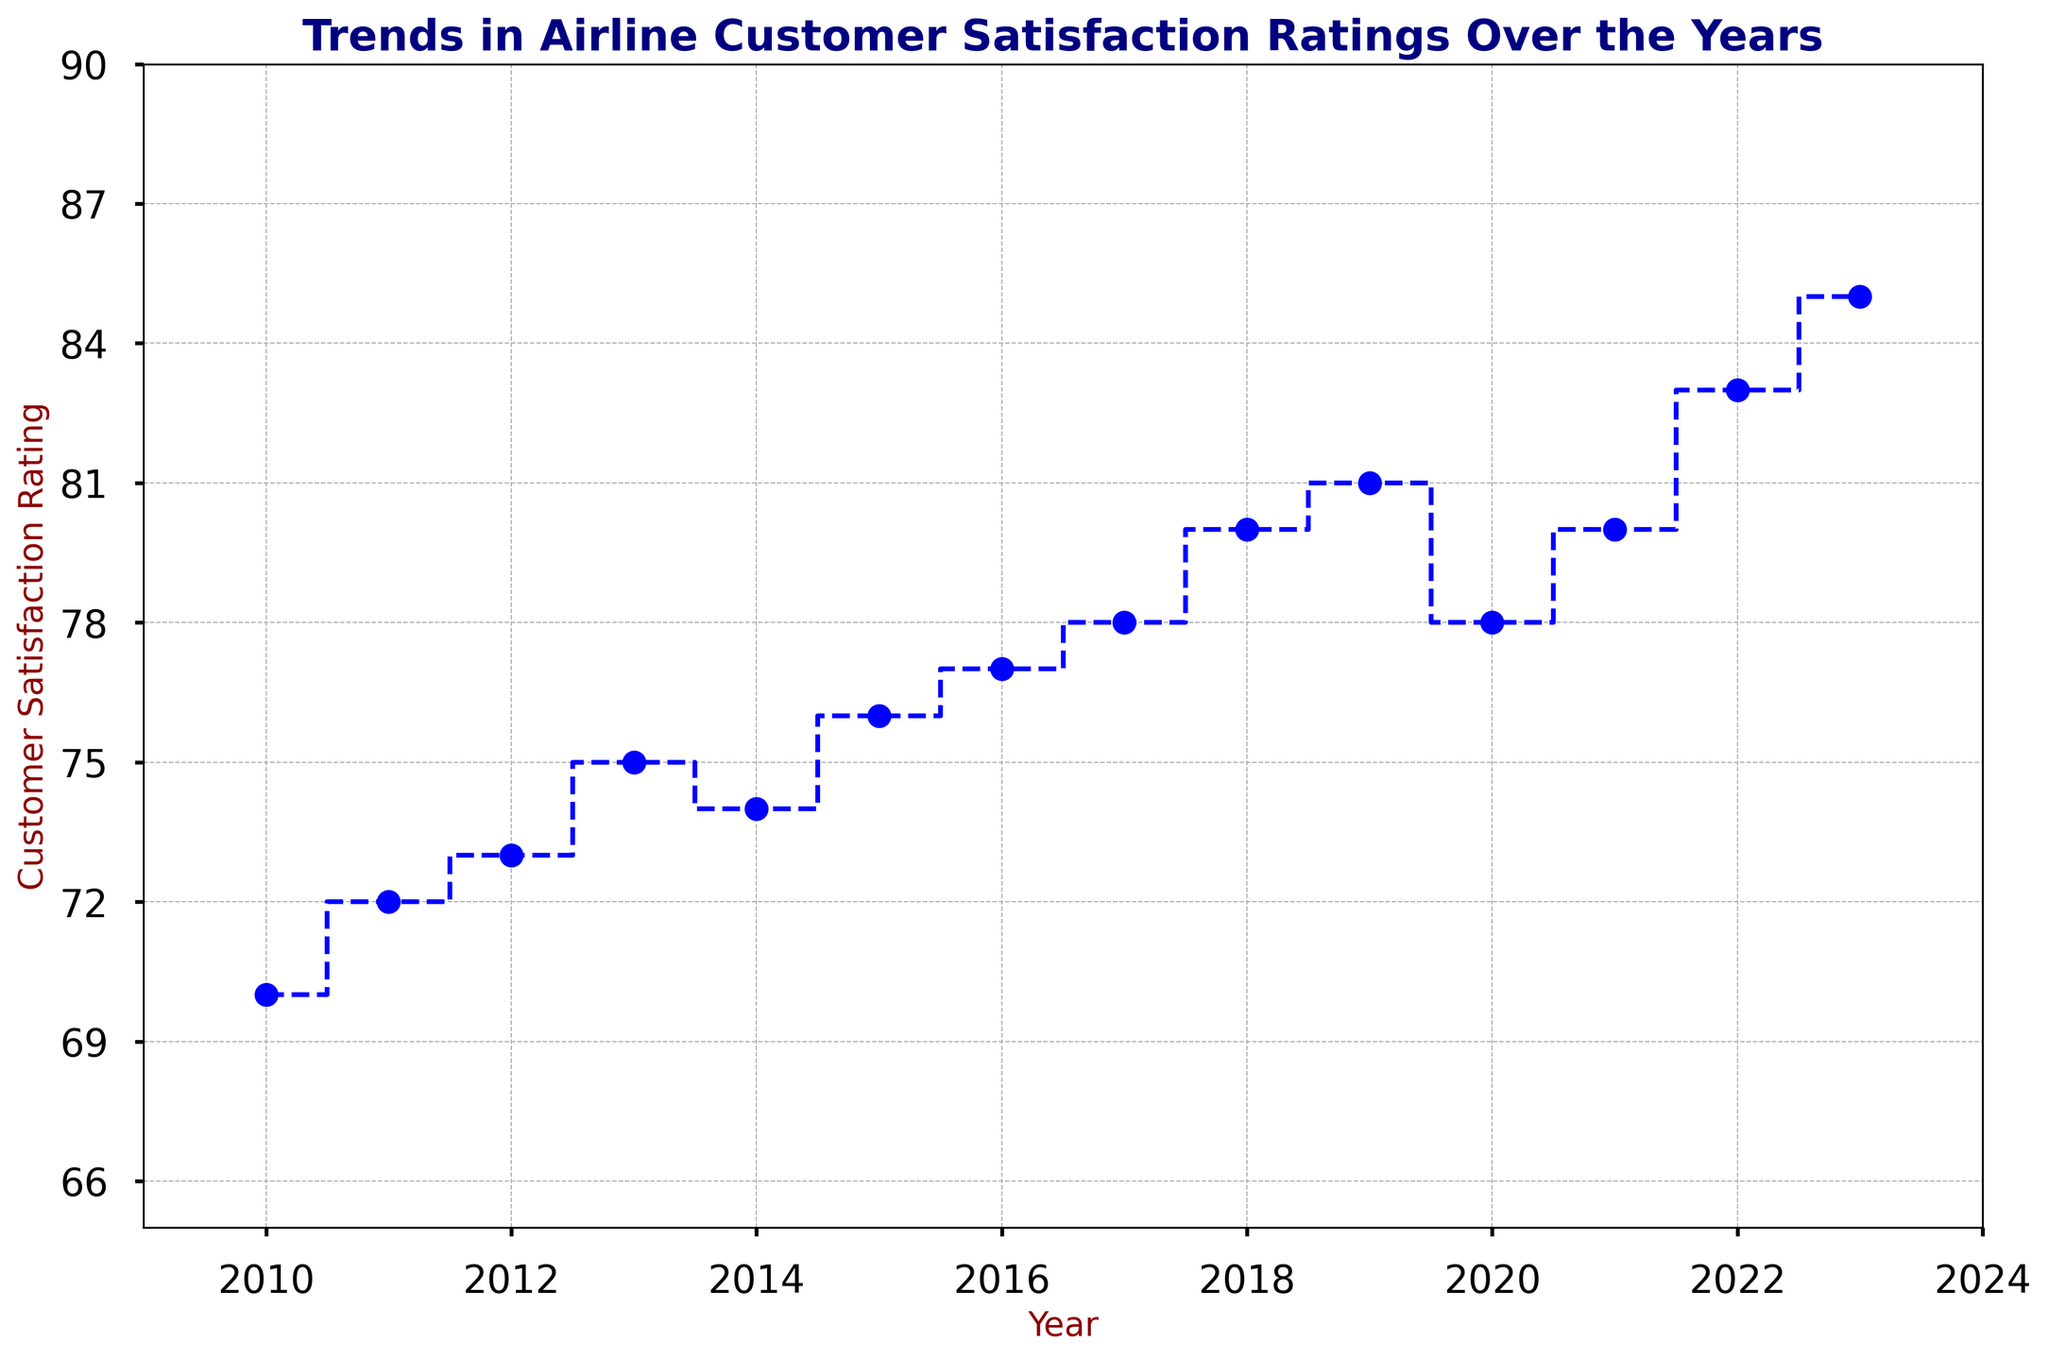What was the customer satisfaction rating in 2013? Look at the plot to find the point corresponding to the year 2013. The satisfaction rating at that point is indicated by the marker.
Answer: 75 How many times did the customer satisfaction rating decrease between consecutive years? Count the number of times the line steps downwards between two consecutive years.
Answer: 2 What is the overall increase in customer satisfaction rating from 2010 to 2023? Subtract the rating in 2010 from the rating in 2023.
Answer: 15 By how much did the customer satisfaction rating change from 2019 to 2020? Subtract the rating in 2019 from the rating in 2020.
Answer: -3 Which year had the highest customer satisfaction rating? Identify the point on the plot with the highest value on the y-axis and note the corresponding year.
Answer: 2023 Which years saw an increase of 2 points in customer satisfaction rating from the previous year? Look for consecutive years where the step increases by exactly 2 points on the y-axis.
Answer: 2011, 2018, 2021 During which period did the customer satisfaction rating remain the same? Look for horizontal steps (no change in y-value) over consecutive years.
Answer: 2020 to 2021 What is the average customer satisfaction rating over the entire period? Sum all the ratings from 2010 to 2023 and divide by the number of years.
Answer: 77.3 Was there a year with a customer satisfaction rating equal to 80? Look for any point on the plot where the y-value is 80 and note the corresponding year(s).
Answer: 2018, 2021 Compare the customer satisfaction rating in 2014 to that in 2015. Observe the y-values for the years 2014 and 2015 and compare them.
Answer: 2015 is higher 